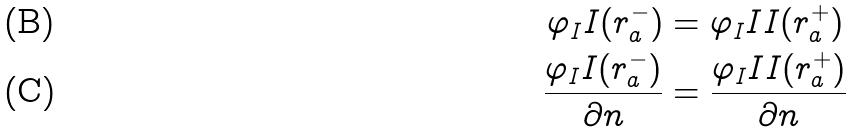Convert formula to latex. <formula><loc_0><loc_0><loc_500><loc_500>\varphi _ { I } I ( r _ { a } ^ { - } ) & = \varphi _ { I } I I ( r _ { a } ^ { + } ) \\ \frac { \varphi _ { I } I ( r _ { a } ^ { - } ) } { \partial n } & = \frac { \varphi _ { I } I I ( r _ { a } ^ { + } ) } { \partial n }</formula> 